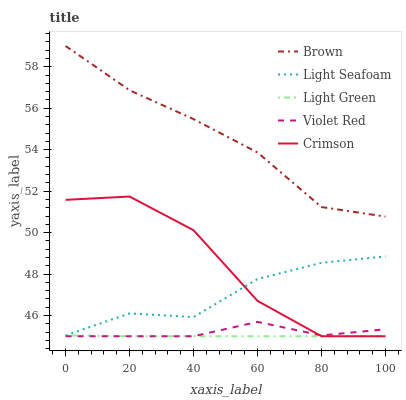Does Violet Red have the minimum area under the curve?
Answer yes or no. No. Does Violet Red have the maximum area under the curve?
Answer yes or no. No. Is Brown the smoothest?
Answer yes or no. No. Is Brown the roughest?
Answer yes or no. No. Does Brown have the lowest value?
Answer yes or no. No. Does Violet Red have the highest value?
Answer yes or no. No. Is Violet Red less than Light Seafoam?
Answer yes or no. Yes. Is Brown greater than Light Seafoam?
Answer yes or no. Yes. Does Violet Red intersect Light Seafoam?
Answer yes or no. No. 